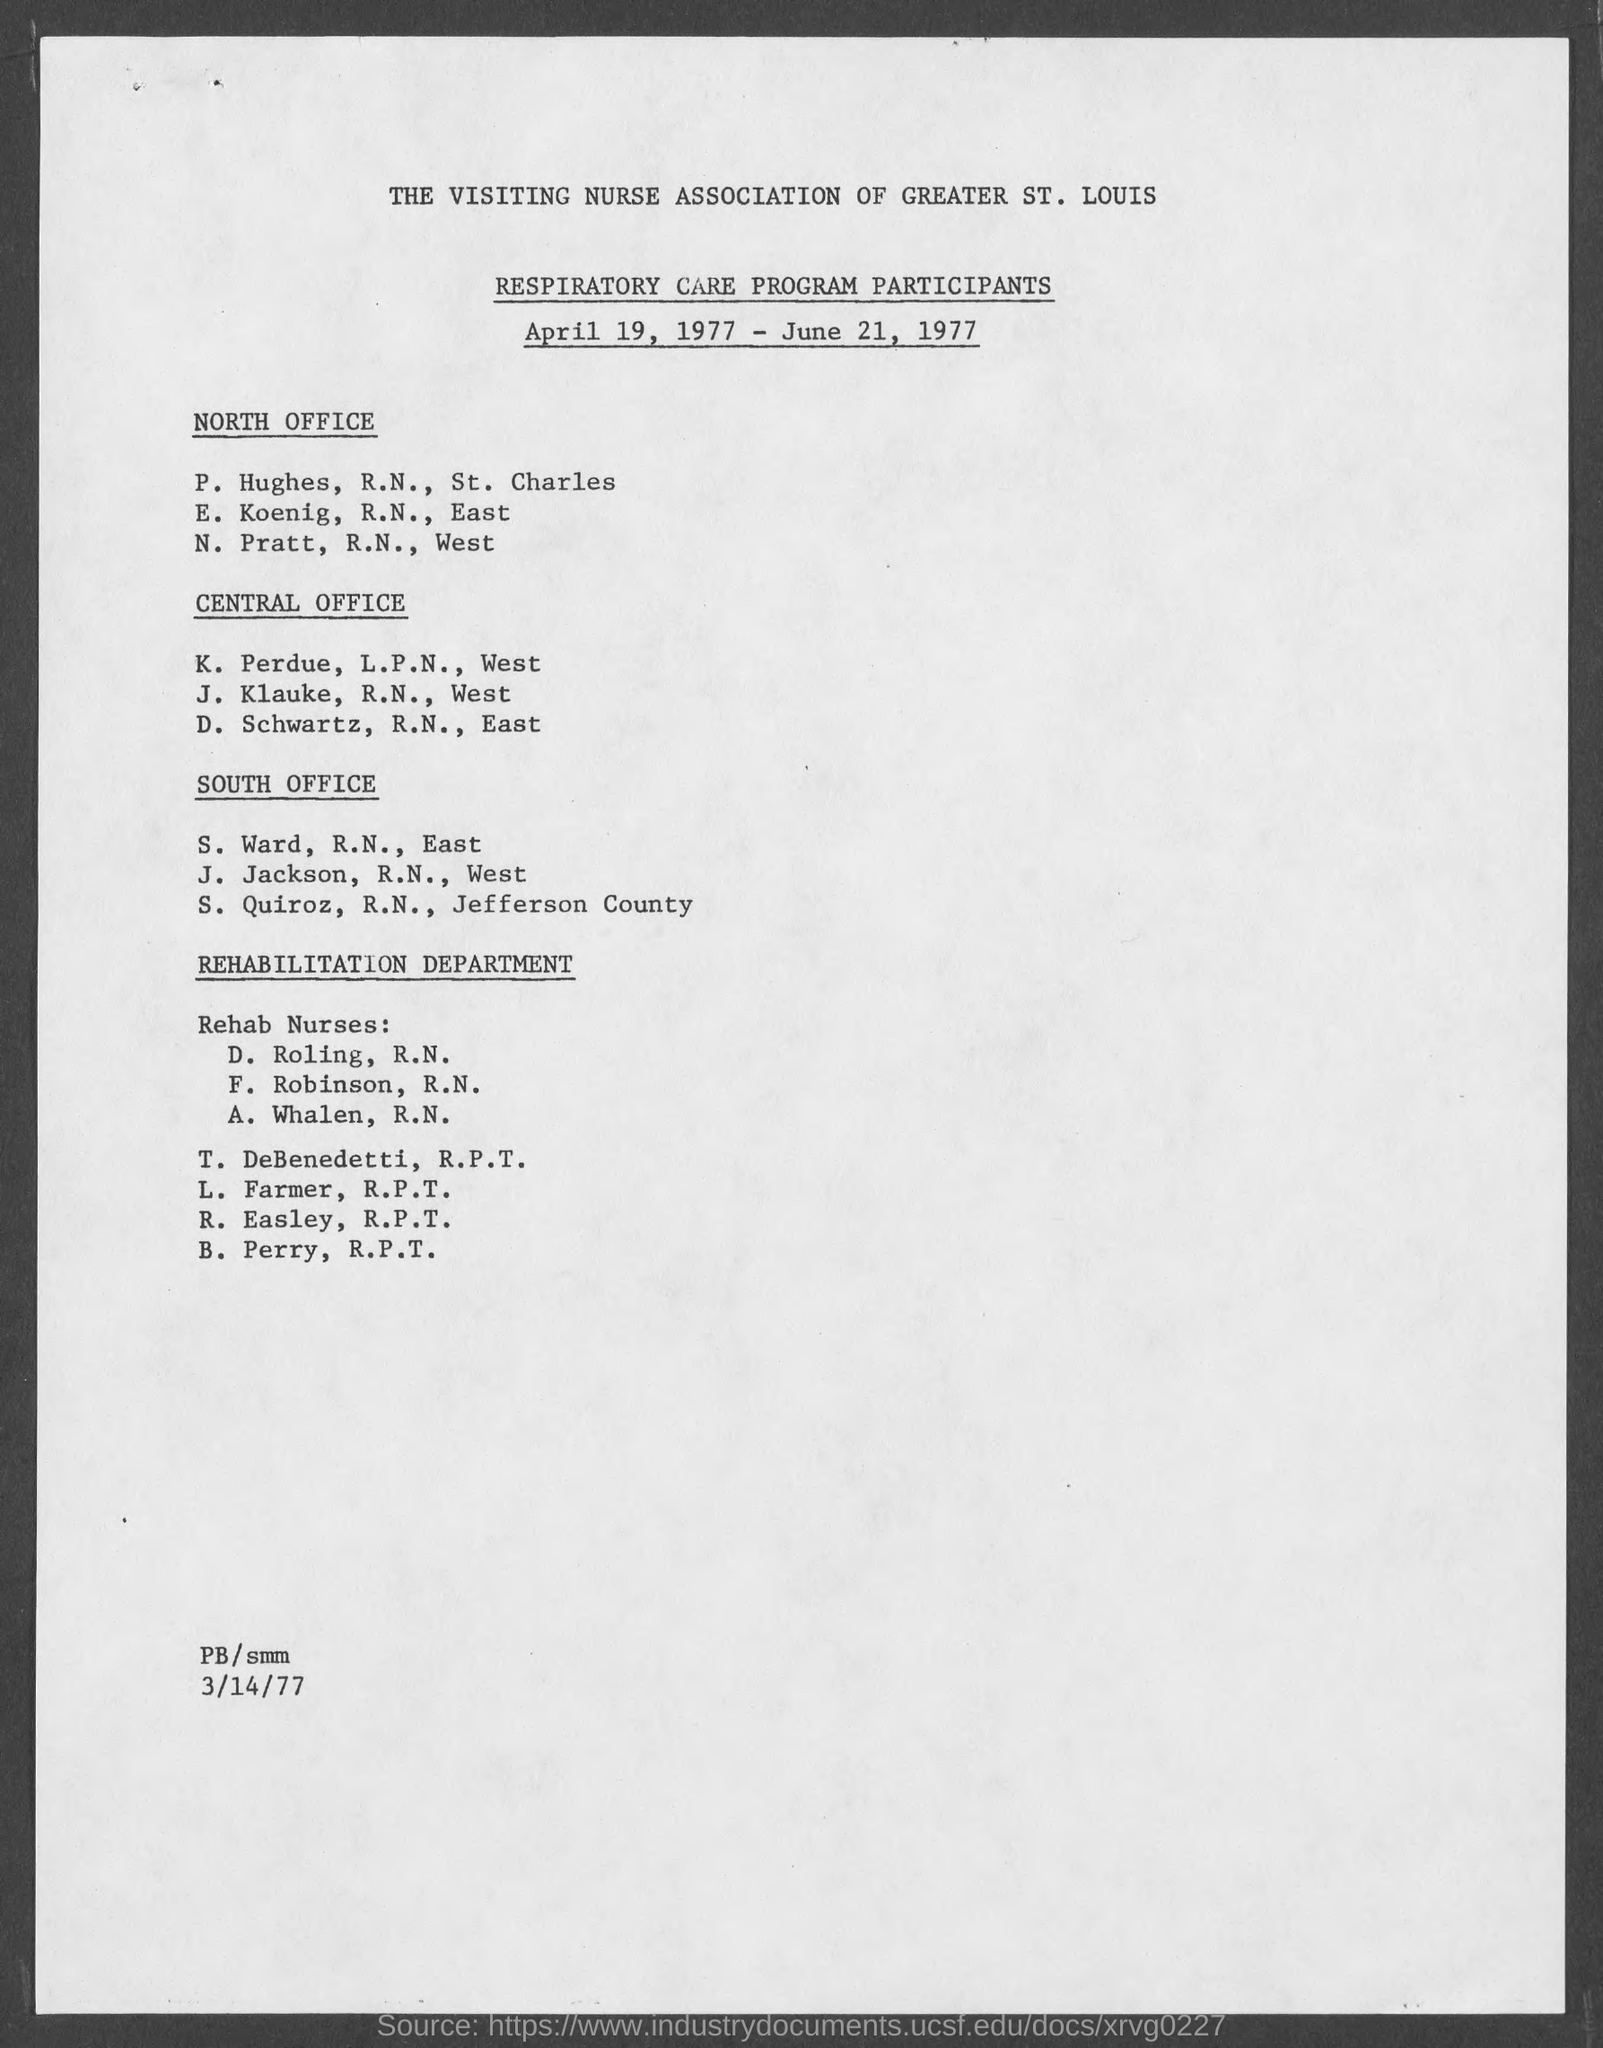Which "PARTICIPANTS" details are given in the document?
Your answer should be compact. RESPIRATORY CARE PROGRAM PARTICIPANTS. Which date is "RESPIRATORY CARE PROGRAM"?
Offer a very short reply. April 19, 1977 -June 21, 1977. When will " "RESPIRATORY CARE PROGRAM" start?
Offer a very short reply. April 19, 1977. When will " "RESPIRATORY CARE PROGRAM" end?
Ensure brevity in your answer.  June 21, 1977. Mention the date given at left bottom corner of the page?
Offer a terse response. 3/14/77. Provide the first side heading given?
Keep it short and to the point. North Office. Mention the participant details given under "NORTH OFFICE" in first line?
Give a very brief answer. Hughes, R.N., St. Charles. Details of "Rehab Nurses:" under which department is given in the list?
Give a very brief answer. REHABILITATION DEPARTMENT. 